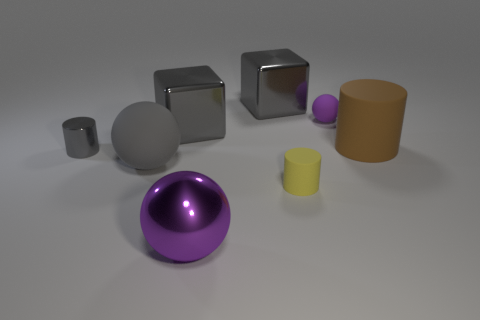Add 2 small metallic balls. How many objects exist? 10 Subtract all blocks. How many objects are left? 6 Subtract all tiny yellow things. Subtract all large purple metallic things. How many objects are left? 6 Add 4 metallic cylinders. How many metallic cylinders are left? 5 Add 2 tiny rubber cubes. How many tiny rubber cubes exist? 2 Subtract 2 purple spheres. How many objects are left? 6 